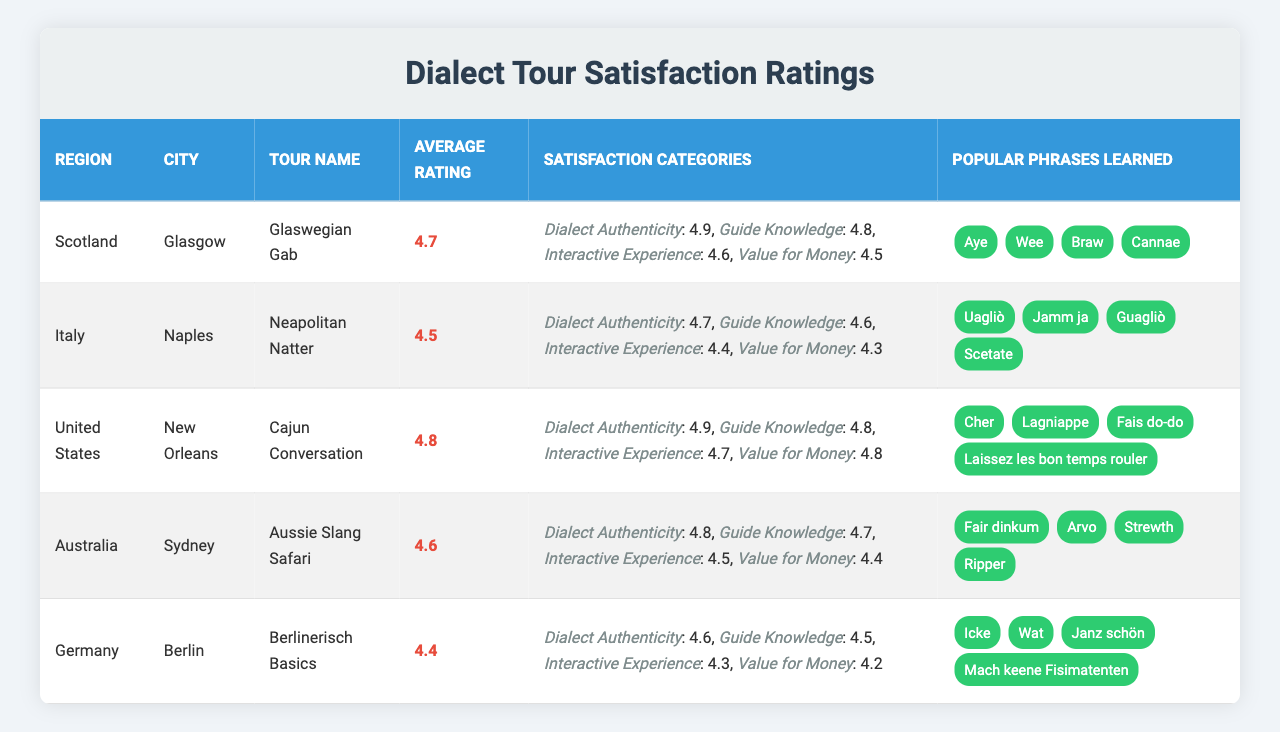What is the average rating for the "Cajun Conversation" tour? The average rating for the "Cajun Conversation" tour, which is located in New Orleans, is mentioned directly in the table. It states an average rating of 4.8.
Answer: 4.8 Which city has the highest rating for "Dialect Authenticity"? By comparing the "Dialect Authenticity" ratings across all tours listed in the table, Sydney has a rating of 4.8, while the other cities have lower ratings.
Answer: Sydney Is "Value for Money" rating higher for "Neapolitan Natter" than for "Berlinerisch Basics"? The "Value for Money" rating for "Neapolitan Natter" is 4.3, and for "Berlinerisch Basics," it is 4.2. Since 4.3 is greater than 4.2, the statement is true.
Answer: Yes Which tour teaches popular phrases like "Cher" and "Lagniappe"? The phrases "Cher" and "Lagniappe" belong to the "Cajun Conversation" tour in New Orleans, as listed in the table under Popular Phrases Learned.
Answer: Cajun Conversation What is the overall average rating of all the tours listed? To find the overall average rating, sum the ratings: (4.7 + 4.5 + 4.8 + 4.6 + 4.4) = 23. Then divide by the number of tours (5) gives: 23 / 5 = 4.6.
Answer: 4.6 Does the "Aussie Slang Safari" have a satisfaction category rating below 4.5? The "Aussie Slang Safari" has the following ratings: Dialect Authenticity (4.8), Guide Knowledge (4.7), Interactive Experience (4.5), and Value for Money (4.4). The "Value for Money" rating is below 4.5, making this statement true.
Answer: Yes Which tour has the best rating for "Guide Knowledge"? Comparing the "Guide Knowledge" ratings, the "Cajun Conversation" tour has the highest rating of 4.8, as mentioned in the table.
Answer: Cajun Conversation Which region offers a tour with the highest average rating among all listed regions? By reviewing average ratings per region, the "Cajun Conversation" with 4.8 from the United States has the highest average rating amongst all tours.
Answer: United States How many popular phrases are learned in the "Glaswegian Gab" tour? The "Glaswegian Gab" tour lists four popular phrases: "Aye", "Wee", "Braw", and "Cannae", which can be counted directly from the table.
Answer: 4 What is the satisfaction rating for "Interactive Experience" in "Neapolitan Natter"? The "Interactive Experience" rating for the "Neapolitan Natter" tour is explicitly listed in the table as 4.4.
Answer: 4.4 